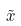Convert formula to latex. <formula><loc_0><loc_0><loc_500><loc_500>\tilde { x }</formula> 